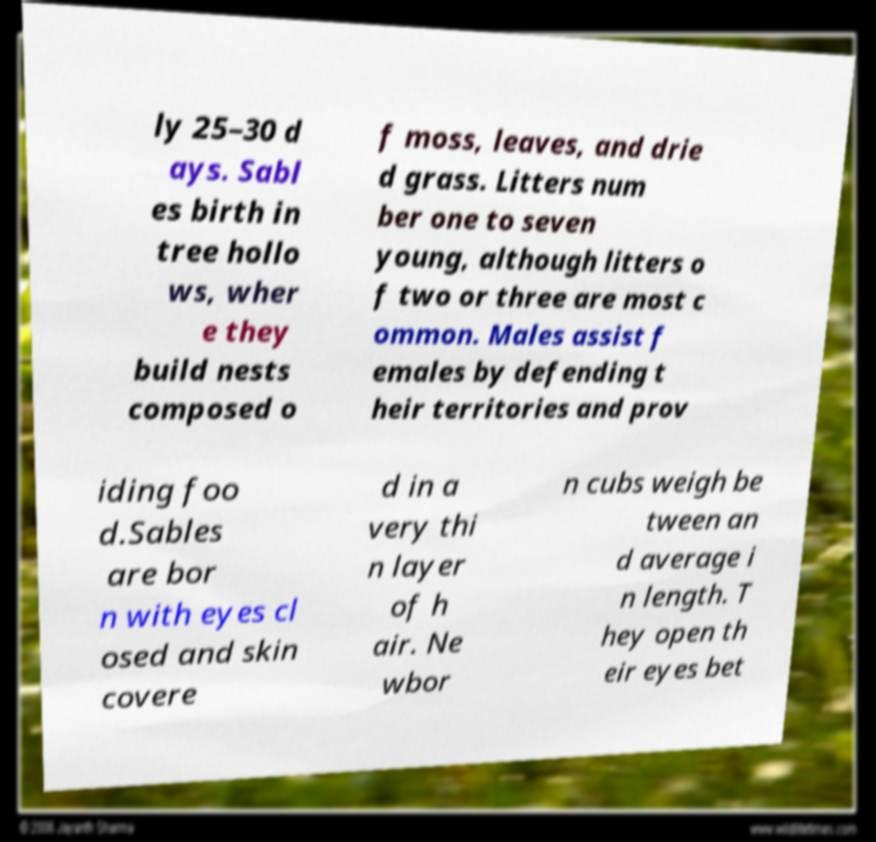There's text embedded in this image that I need extracted. Can you transcribe it verbatim? ly 25–30 d ays. Sabl es birth in tree hollo ws, wher e they build nests composed o f moss, leaves, and drie d grass. Litters num ber one to seven young, although litters o f two or three are most c ommon. Males assist f emales by defending t heir territories and prov iding foo d.Sables are bor n with eyes cl osed and skin covere d in a very thi n layer of h air. Ne wbor n cubs weigh be tween an d average i n length. T hey open th eir eyes bet 